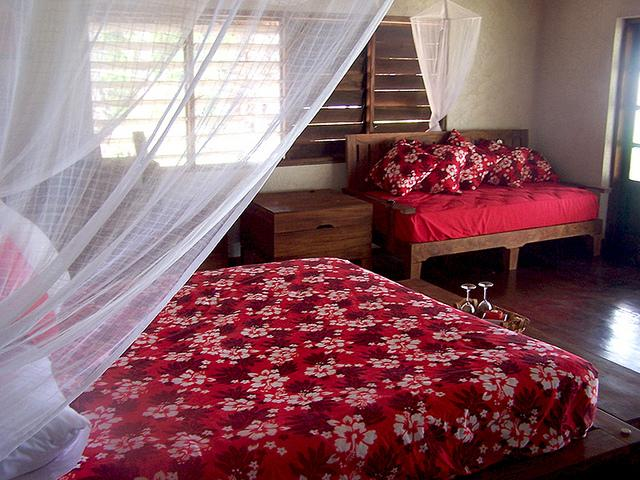What holiday is the color pattern on the bed most appropriate for?

Choices:
A) halloween
B) valentines day
C) thanksgiving
D) arbor day valentines day 